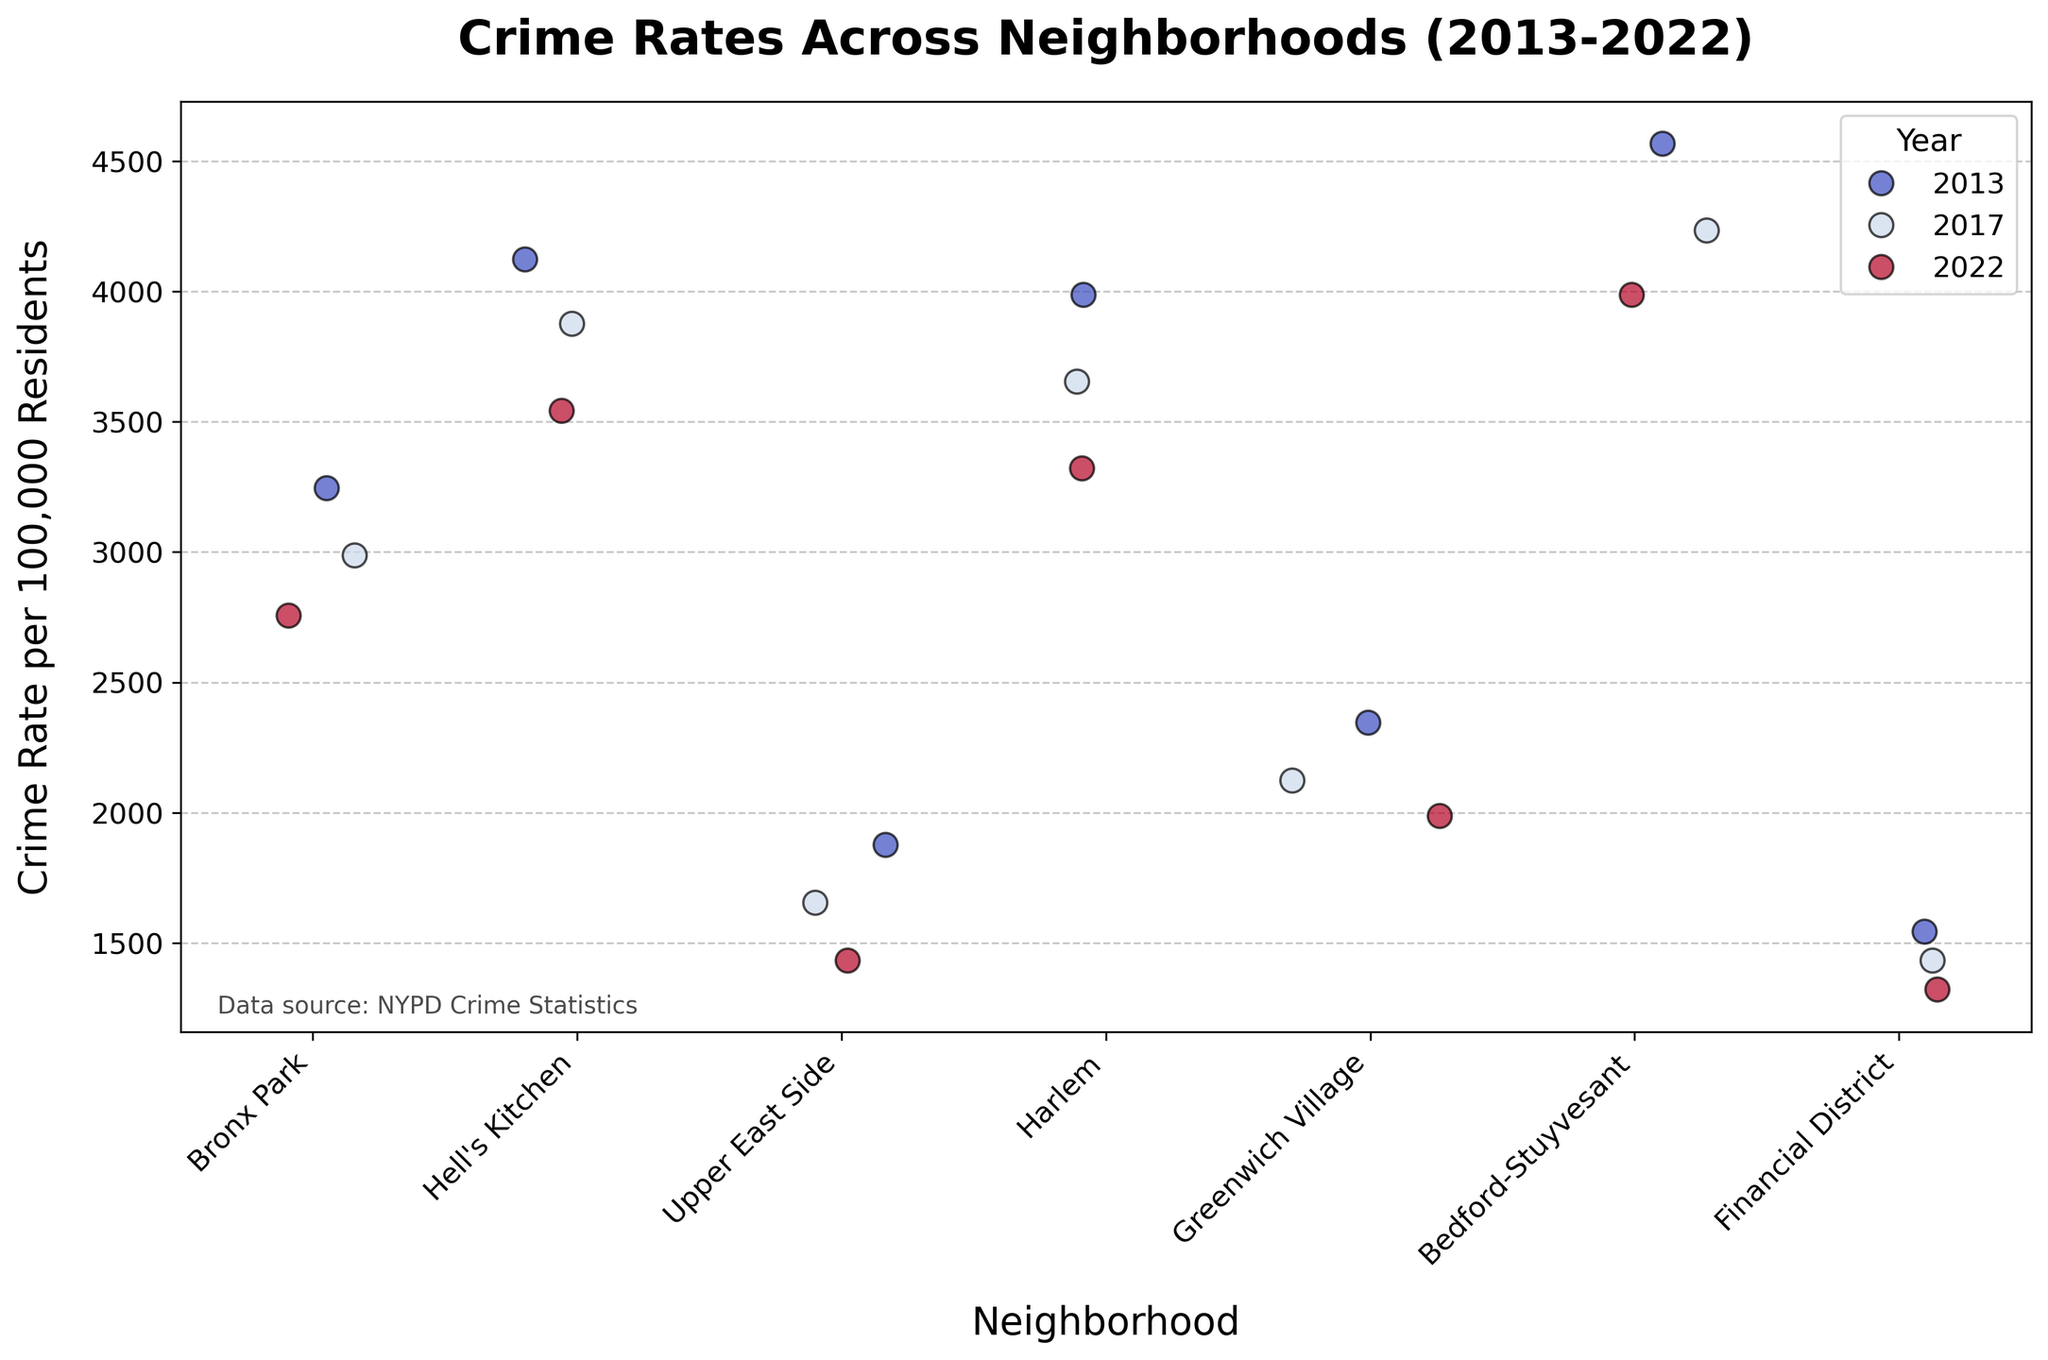What is the title of the strip plot? The title of the strip plot can be found on top of the figure, which is centrally aligned.
Answer: Crime Rates Across Neighborhoods (2013-2022) Which neighborhood had the highest crime rate in 2013? The highest dots for 2013 in different neighborhoods need to be checked. Bedford-Stuyvesant had the highest dot at 4567 in 2013.
Answer: Bedford-Stuyvesant How does the 2022 crime rate in Hell's Kitchen compare to Bronx Park's 2022 crime rate? Locate both neighborhoods and compare the height of their dots for 2022. Hell's Kitchen at 3542 is higher than Bronx Park at 2756.
Answer: Hell's Kitchen is higher Which year shows the highest crime rate in Upper East Side? Compare the uppermost dots for each year within the Upper East Side neighborhood. The dot for 2013 is the highest at 1876.
Answer: 2013 What is the average crime rate in Financial District across the three years? Add up the crime rates for each year (1543 + 1432 + 1321) and divide by 3. (1543 + 1432 + 1321) / 3 = 1432
Answer: 1432 How much did the crime rate decrease in Greenwich Village from 2013 to 2022? Subtract the 2022 crime rate from the 2013 crime rate for Greenwich Village. 2345 - 1987 = 358
Answer: 358 Which neighborhood shows a continuous decrease in crime rates over the years? Look for neighborhoods where the dots keep lowering consistently. Upper East Side shows a continuous decrease from 1876 to 1432.
Answer: Upper East Side What is the difference in crime rate between Harlem and Bedford-Stuyvesant in 2017? Subtract Harlem’s dot for 2017 from Bedford-Stuyvesant’s dot for 2017. 4234 - 3654 = 580
Answer: 580 In which neighborhood is the crime rate in 2022 closest to the 2017 crime rate in Greenwich Village? Compare the 2022 dots of all neighborhoods to Greenwich Village's 2017 rate of 2123. Bronx Park's 2022 rate of 2756 is closest.
Answer: Bronx Park What do the colors represent in the strip plot? The legend at the top right indicates that the colors represent different years (2013, 2017, and 2022) using a cool-warm palette.
Answer: Different years (2013, 2017, 2022) 